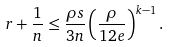<formula> <loc_0><loc_0><loc_500><loc_500>r + \frac { 1 } { n } \leq \frac { \rho s } { 3 n } \left ( \frac { \rho } { 1 2 e } \right ) ^ { k - 1 } .</formula> 